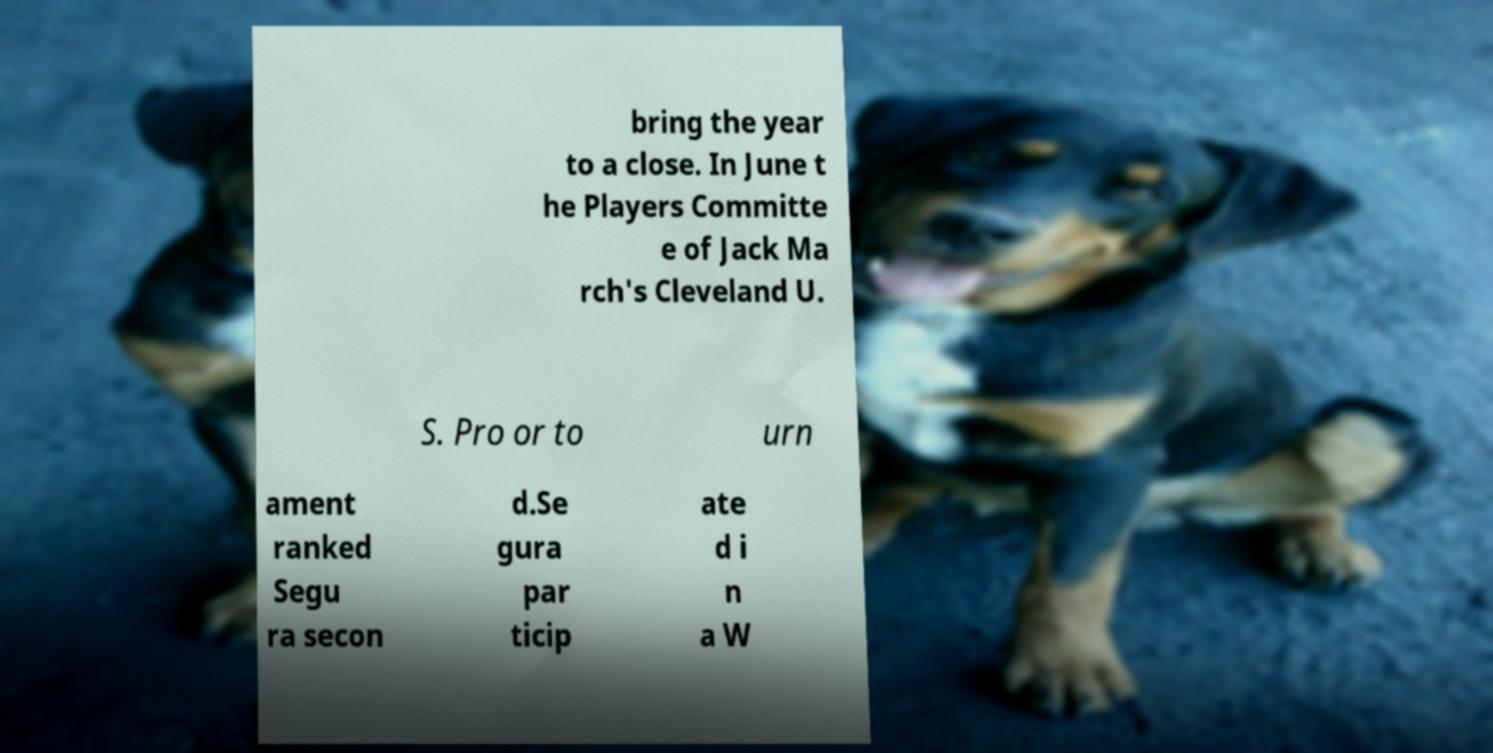Please identify and transcribe the text found in this image. bring the year to a close. In June t he Players Committe e of Jack Ma rch's Cleveland U. S. Pro or to urn ament ranked Segu ra secon d.Se gura par ticip ate d i n a W 